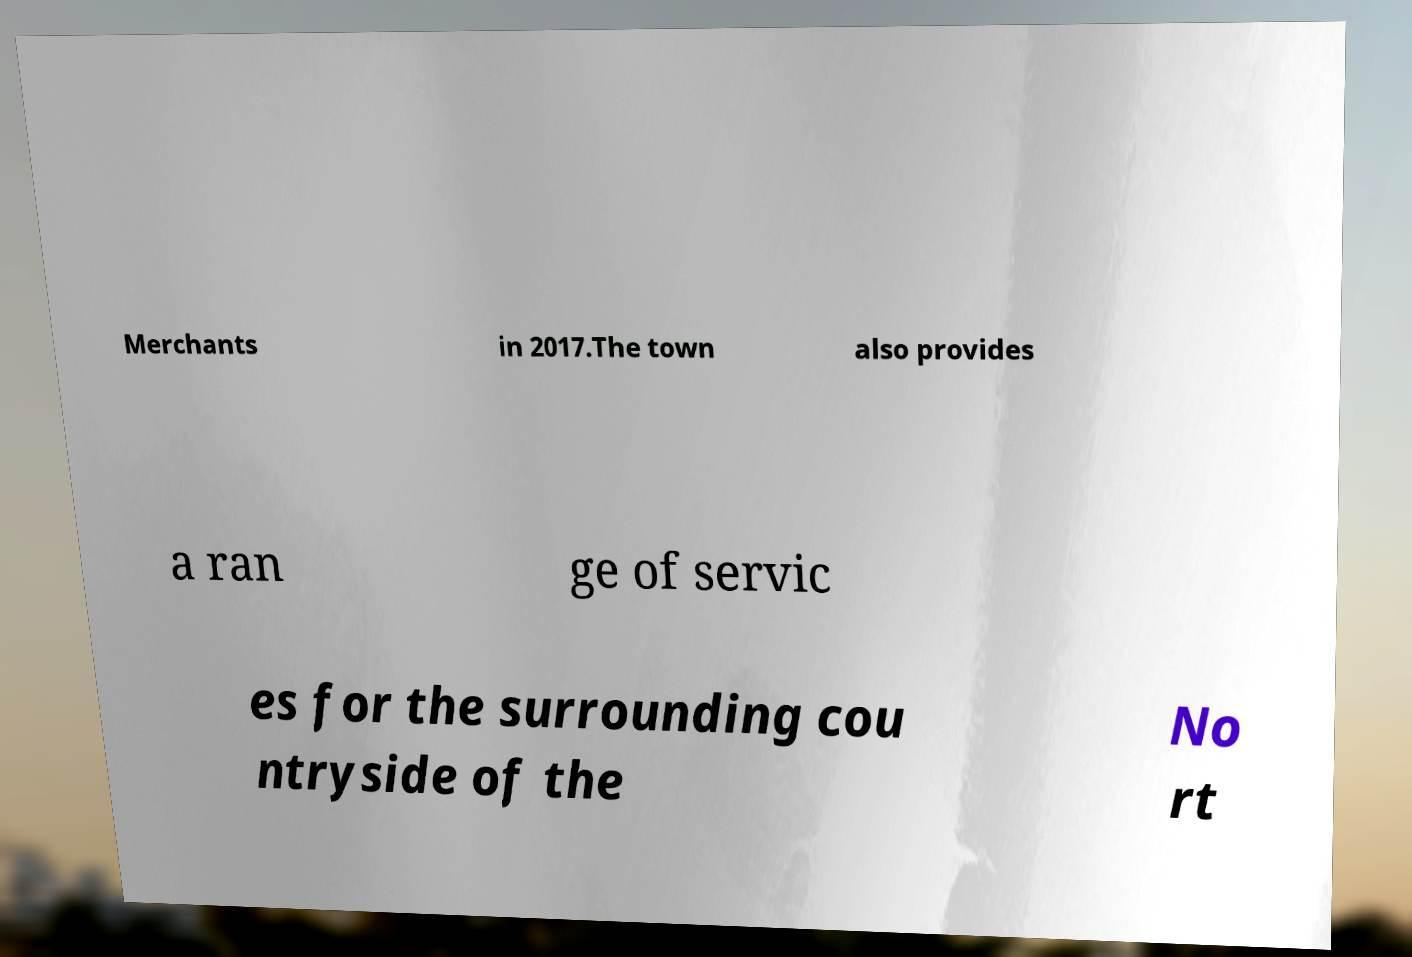For documentation purposes, I need the text within this image transcribed. Could you provide that? Merchants in 2017.The town also provides a ran ge of servic es for the surrounding cou ntryside of the No rt 